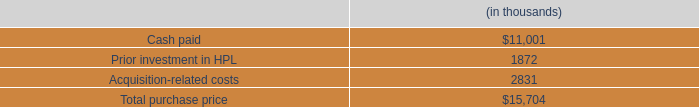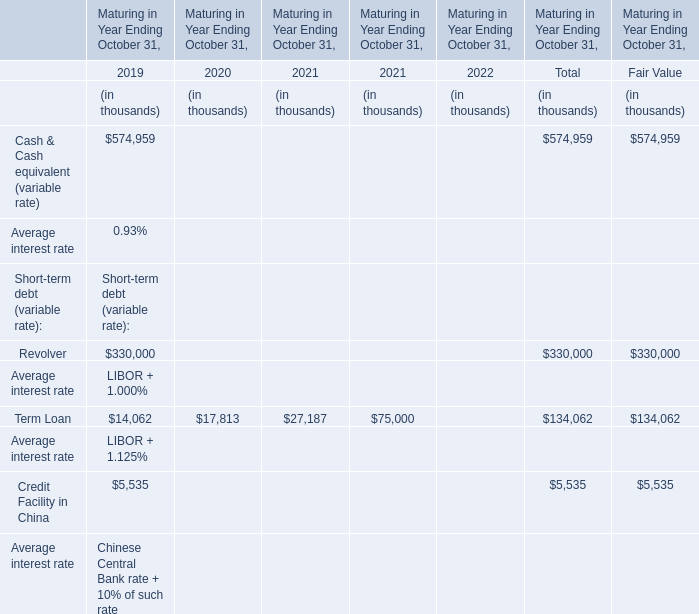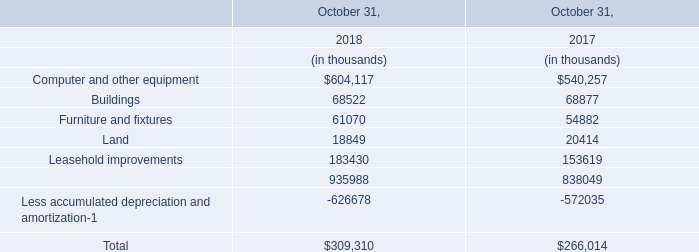What's the value of the Term Loan Maturing in 2020 Ending October 31? (in thousand) 
Answer: 17813. 